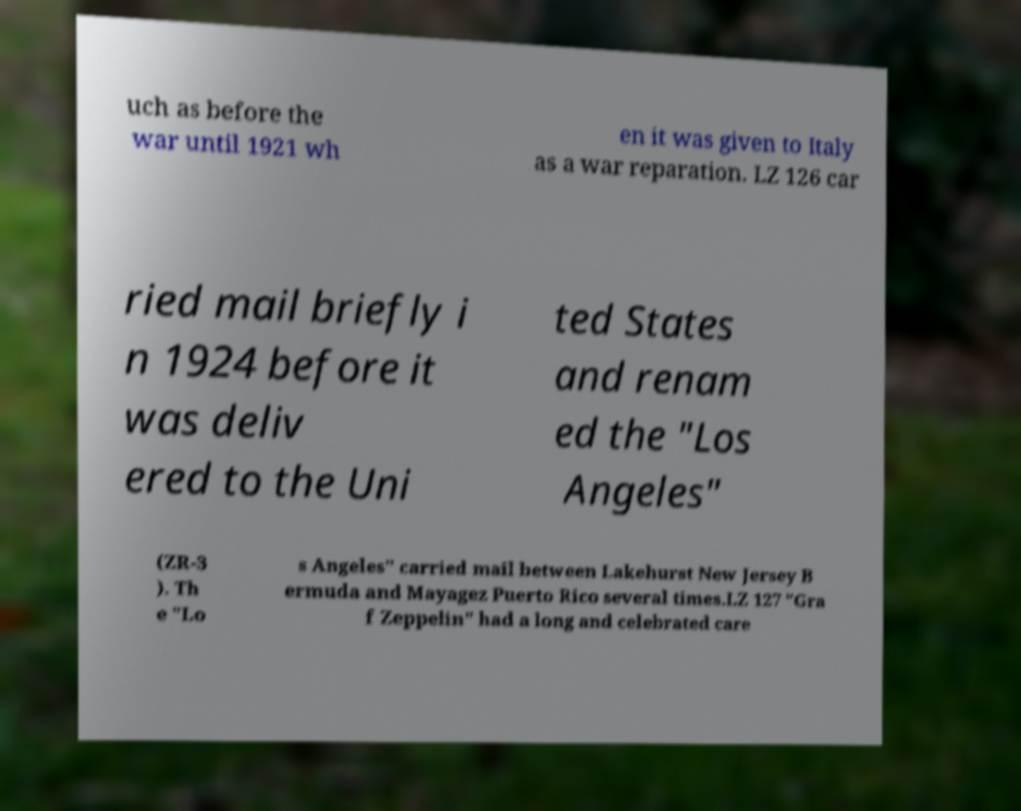Can you accurately transcribe the text from the provided image for me? uch as before the war until 1921 wh en it was given to Italy as a war reparation. LZ 126 car ried mail briefly i n 1924 before it was deliv ered to the Uni ted States and renam ed the "Los Angeles" (ZR-3 ). Th e "Lo s Angeles" carried mail between Lakehurst New Jersey B ermuda and Mayagez Puerto Rico several times.LZ 127 "Gra f Zeppelin" had a long and celebrated care 